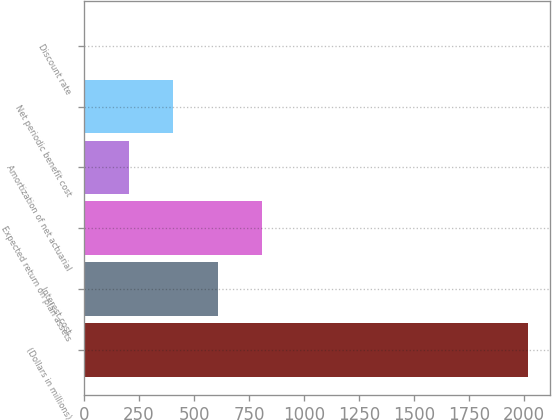<chart> <loc_0><loc_0><loc_500><loc_500><bar_chart><fcel>(Dollars in millions)<fcel>Interest cost<fcel>Expected return on plan assets<fcel>Amortization of net actuarial<fcel>Net periodic benefit cost<fcel>Discount rate<nl><fcel>2015<fcel>606.98<fcel>808.12<fcel>204.7<fcel>405.84<fcel>3.56<nl></chart> 